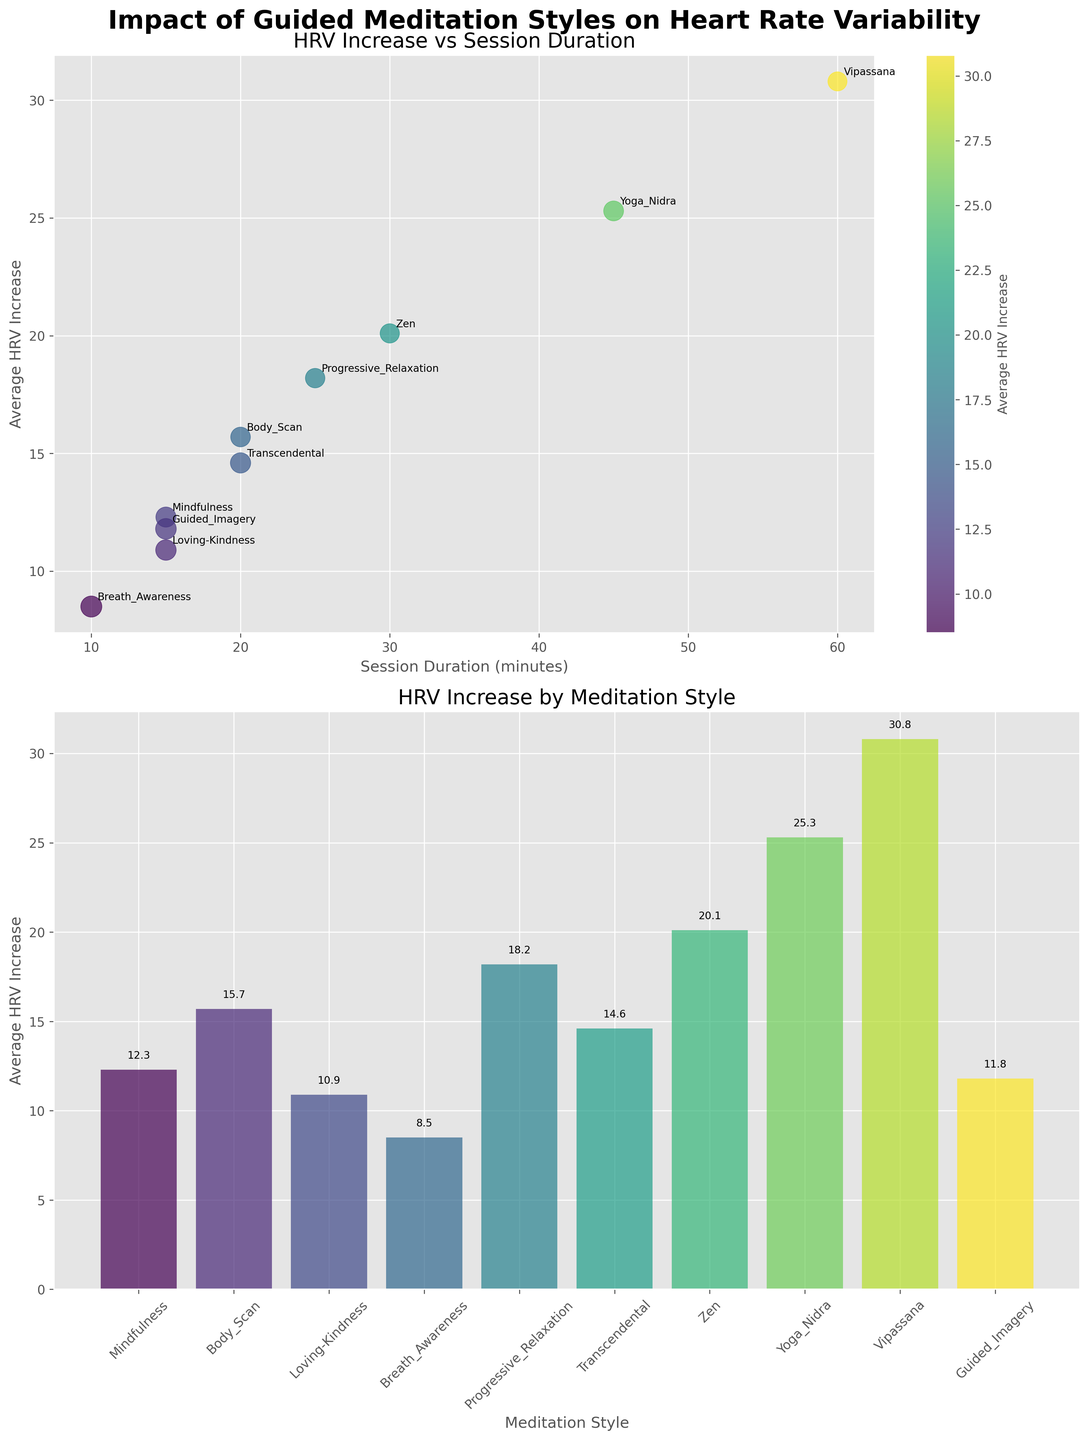How many different meditation styles are compared in this figure? The bar chart in Subplot 2 lists the number of meditation styles. Counting the bars, there are a total of 10 different meditation styles.
Answer: 10 Which meditation style shows the highest average HRV increase? By observing the bar heights in Subplot 2, we see that Vipassana has the tallest bar, indicating the highest average HRV increase.
Answer: Vipassana What's the total number of participants across all meditation styles? Summing the 'Participants' values for each meditation style from the scatter plot in Subplot 1: 50 + 48 + 52 + 55 + 47 + 51 + 46 + 49 + 45 + 53 = 496.
Answer: 496 Which two meditation styles require the longest session durations? From the scatter plot in Subplot 1 and the x-axis for session duration, Vipassana (60 minutes) and Yoga Nidra (45 minutes) have the longest session durations.
Answer: Vipassana and Yoga Nidra How does the session duration correlate with the average HRV increase? In Subplot 1, the scatter plot shows a positive correlation where longer session durations tend to associate with higher average HRV increases.
Answer: Positive correlation What is the average HRV increase of mindfulness compared to guided imagery? In Subplot 2, the heights of the bars for Mindfulness and Guided Imagery show their average HRV increases, which are 12.3 and 11.8 respectively. Comparing them, Mindfulness has a slightly higher average HRV increase than Guided Imagery.
Answer: Mindfulness is higher Which meditation style has the smallest circle size in Subplot 1? The size of circles in Subplot 1 corresponds to the number of participants. The smallest circle appears to be Vipassana, which means it has the fewest participants.
Answer: Vipassana What's the difference in average HRV increase between Progressive Relaxation and Breath Awareness? From Subplot 2, the average HRV increase for Progressive Relaxation is 18.2 and for Breath Awareness, it is 8.5. The difference is 18.2 - 8.5 = 9.7.
Answer: 9.7 Which meditation styles have a session duration of 15 minutes? In Subplot 1, observing the x-axis position with session duration of 15 minutes, the meditation styles are Mindfulness, Loving-Kindness, and Guided Imagery.
Answer: Mindfulness, Loving-Kindness, and Guided Imagery 